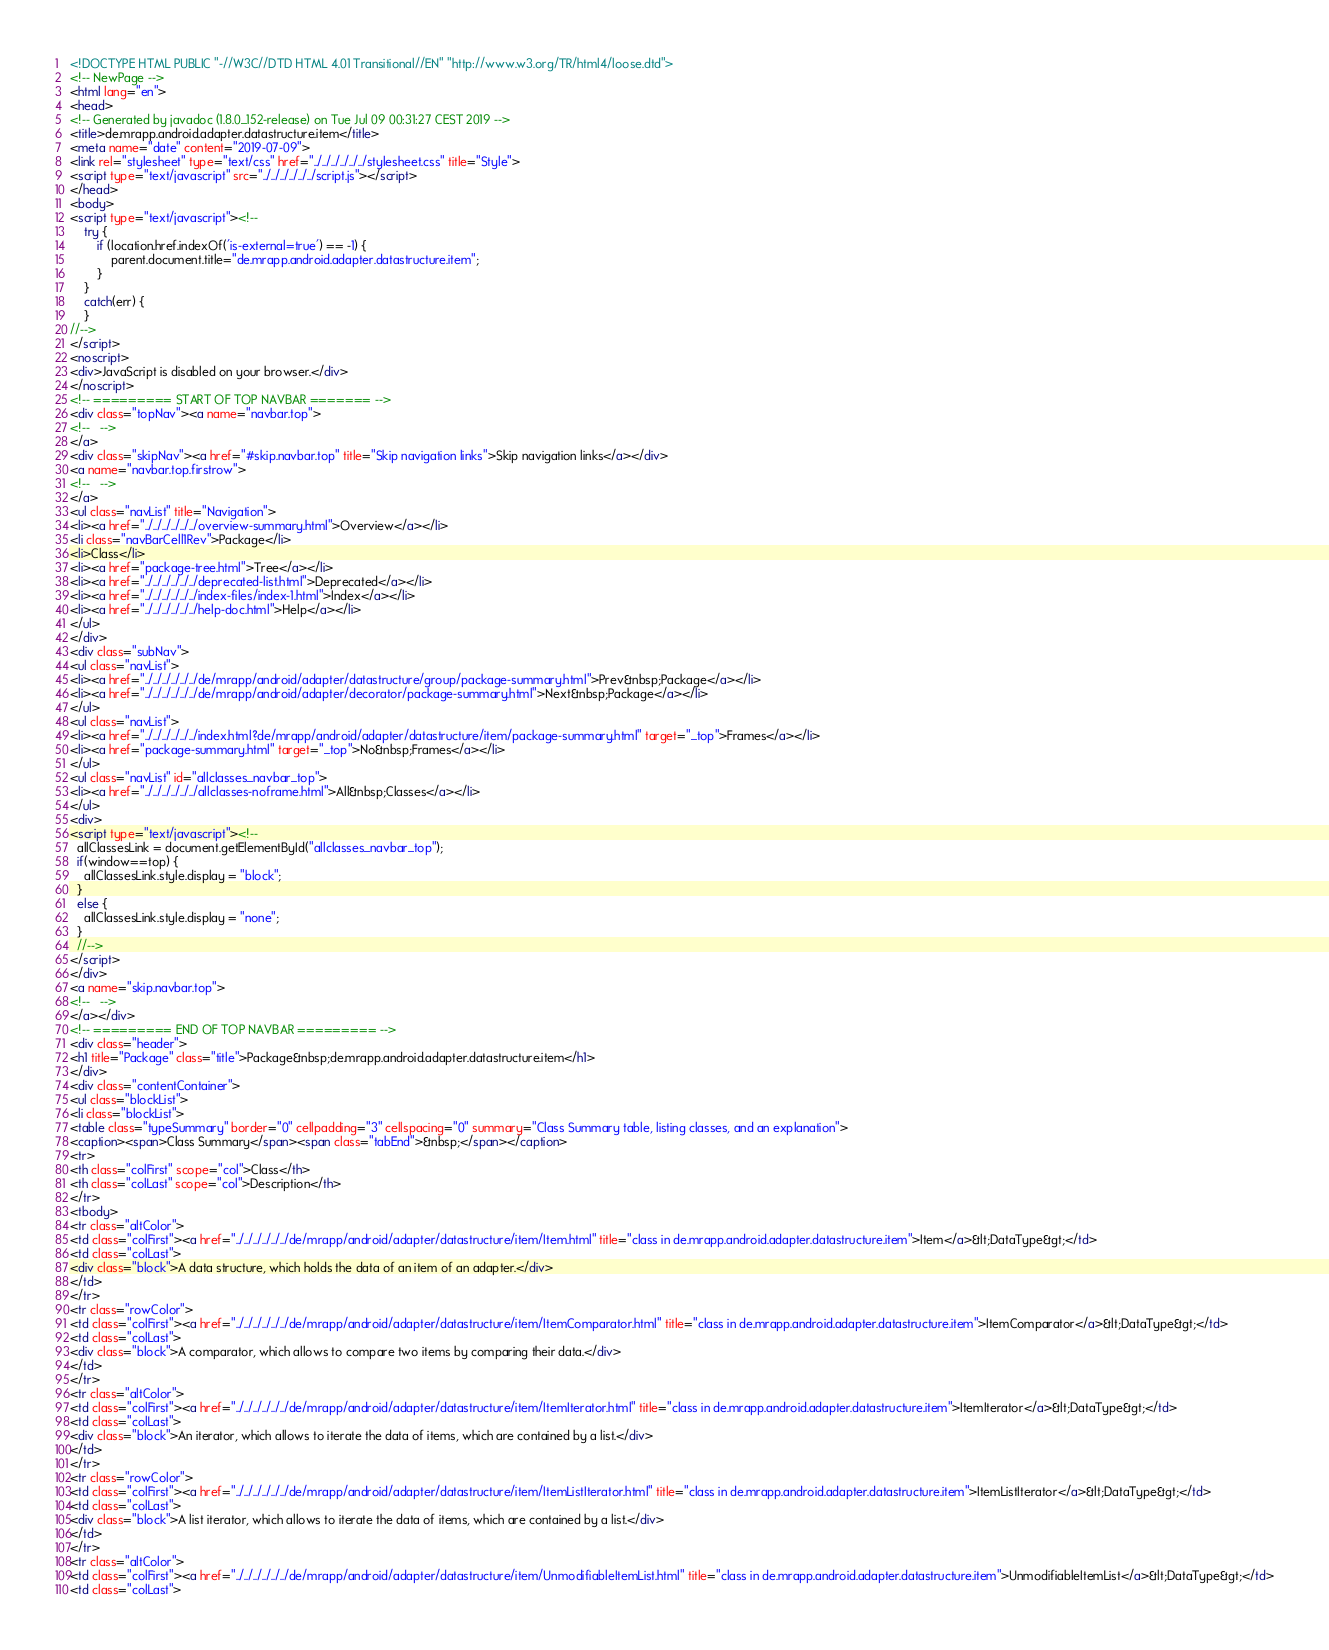Convert code to text. <code><loc_0><loc_0><loc_500><loc_500><_HTML_><!DOCTYPE HTML PUBLIC "-//W3C//DTD HTML 4.01 Transitional//EN" "http://www.w3.org/TR/html4/loose.dtd">
<!-- NewPage -->
<html lang="en">
<head>
<!-- Generated by javadoc (1.8.0_152-release) on Tue Jul 09 00:31:27 CEST 2019 -->
<title>de.mrapp.android.adapter.datastructure.item</title>
<meta name="date" content="2019-07-09">
<link rel="stylesheet" type="text/css" href="../../../../../../stylesheet.css" title="Style">
<script type="text/javascript" src="../../../../../../script.js"></script>
</head>
<body>
<script type="text/javascript"><!--
    try {
        if (location.href.indexOf('is-external=true') == -1) {
            parent.document.title="de.mrapp.android.adapter.datastructure.item";
        }
    }
    catch(err) {
    }
//-->
</script>
<noscript>
<div>JavaScript is disabled on your browser.</div>
</noscript>
<!-- ========= START OF TOP NAVBAR ======= -->
<div class="topNav"><a name="navbar.top">
<!--   -->
</a>
<div class="skipNav"><a href="#skip.navbar.top" title="Skip navigation links">Skip navigation links</a></div>
<a name="navbar.top.firstrow">
<!--   -->
</a>
<ul class="navList" title="Navigation">
<li><a href="../../../../../../overview-summary.html">Overview</a></li>
<li class="navBarCell1Rev">Package</li>
<li>Class</li>
<li><a href="package-tree.html">Tree</a></li>
<li><a href="../../../../../../deprecated-list.html">Deprecated</a></li>
<li><a href="../../../../../../index-files/index-1.html">Index</a></li>
<li><a href="../../../../../../help-doc.html">Help</a></li>
</ul>
</div>
<div class="subNav">
<ul class="navList">
<li><a href="../../../../../../de/mrapp/android/adapter/datastructure/group/package-summary.html">Prev&nbsp;Package</a></li>
<li><a href="../../../../../../de/mrapp/android/adapter/decorator/package-summary.html">Next&nbsp;Package</a></li>
</ul>
<ul class="navList">
<li><a href="../../../../../../index.html?de/mrapp/android/adapter/datastructure/item/package-summary.html" target="_top">Frames</a></li>
<li><a href="package-summary.html" target="_top">No&nbsp;Frames</a></li>
</ul>
<ul class="navList" id="allclasses_navbar_top">
<li><a href="../../../../../../allclasses-noframe.html">All&nbsp;Classes</a></li>
</ul>
<div>
<script type="text/javascript"><!--
  allClassesLink = document.getElementById("allclasses_navbar_top");
  if(window==top) {
    allClassesLink.style.display = "block";
  }
  else {
    allClassesLink.style.display = "none";
  }
  //-->
</script>
</div>
<a name="skip.navbar.top">
<!--   -->
</a></div>
<!-- ========= END OF TOP NAVBAR ========= -->
<div class="header">
<h1 title="Package" class="title">Package&nbsp;de.mrapp.android.adapter.datastructure.item</h1>
</div>
<div class="contentContainer">
<ul class="blockList">
<li class="blockList">
<table class="typeSummary" border="0" cellpadding="3" cellspacing="0" summary="Class Summary table, listing classes, and an explanation">
<caption><span>Class Summary</span><span class="tabEnd">&nbsp;</span></caption>
<tr>
<th class="colFirst" scope="col">Class</th>
<th class="colLast" scope="col">Description</th>
</tr>
<tbody>
<tr class="altColor">
<td class="colFirst"><a href="../../../../../../de/mrapp/android/adapter/datastructure/item/Item.html" title="class in de.mrapp.android.adapter.datastructure.item">Item</a>&lt;DataType&gt;</td>
<td class="colLast">
<div class="block">A data structure, which holds the data of an item of an adapter.</div>
</td>
</tr>
<tr class="rowColor">
<td class="colFirst"><a href="../../../../../../de/mrapp/android/adapter/datastructure/item/ItemComparator.html" title="class in de.mrapp.android.adapter.datastructure.item">ItemComparator</a>&lt;DataType&gt;</td>
<td class="colLast">
<div class="block">A comparator, which allows to compare two items by comparing their data.</div>
</td>
</tr>
<tr class="altColor">
<td class="colFirst"><a href="../../../../../../de/mrapp/android/adapter/datastructure/item/ItemIterator.html" title="class in de.mrapp.android.adapter.datastructure.item">ItemIterator</a>&lt;DataType&gt;</td>
<td class="colLast">
<div class="block">An iterator, which allows to iterate the data of items, which are contained by a list.</div>
</td>
</tr>
<tr class="rowColor">
<td class="colFirst"><a href="../../../../../../de/mrapp/android/adapter/datastructure/item/ItemListIterator.html" title="class in de.mrapp.android.adapter.datastructure.item">ItemListIterator</a>&lt;DataType&gt;</td>
<td class="colLast">
<div class="block">A list iterator, which allows to iterate the data of items, which are contained by a list.</div>
</td>
</tr>
<tr class="altColor">
<td class="colFirst"><a href="../../../../../../de/mrapp/android/adapter/datastructure/item/UnmodifiableItemList.html" title="class in de.mrapp.android.adapter.datastructure.item">UnmodifiableItemList</a>&lt;DataType&gt;</td>
<td class="colLast"></code> 